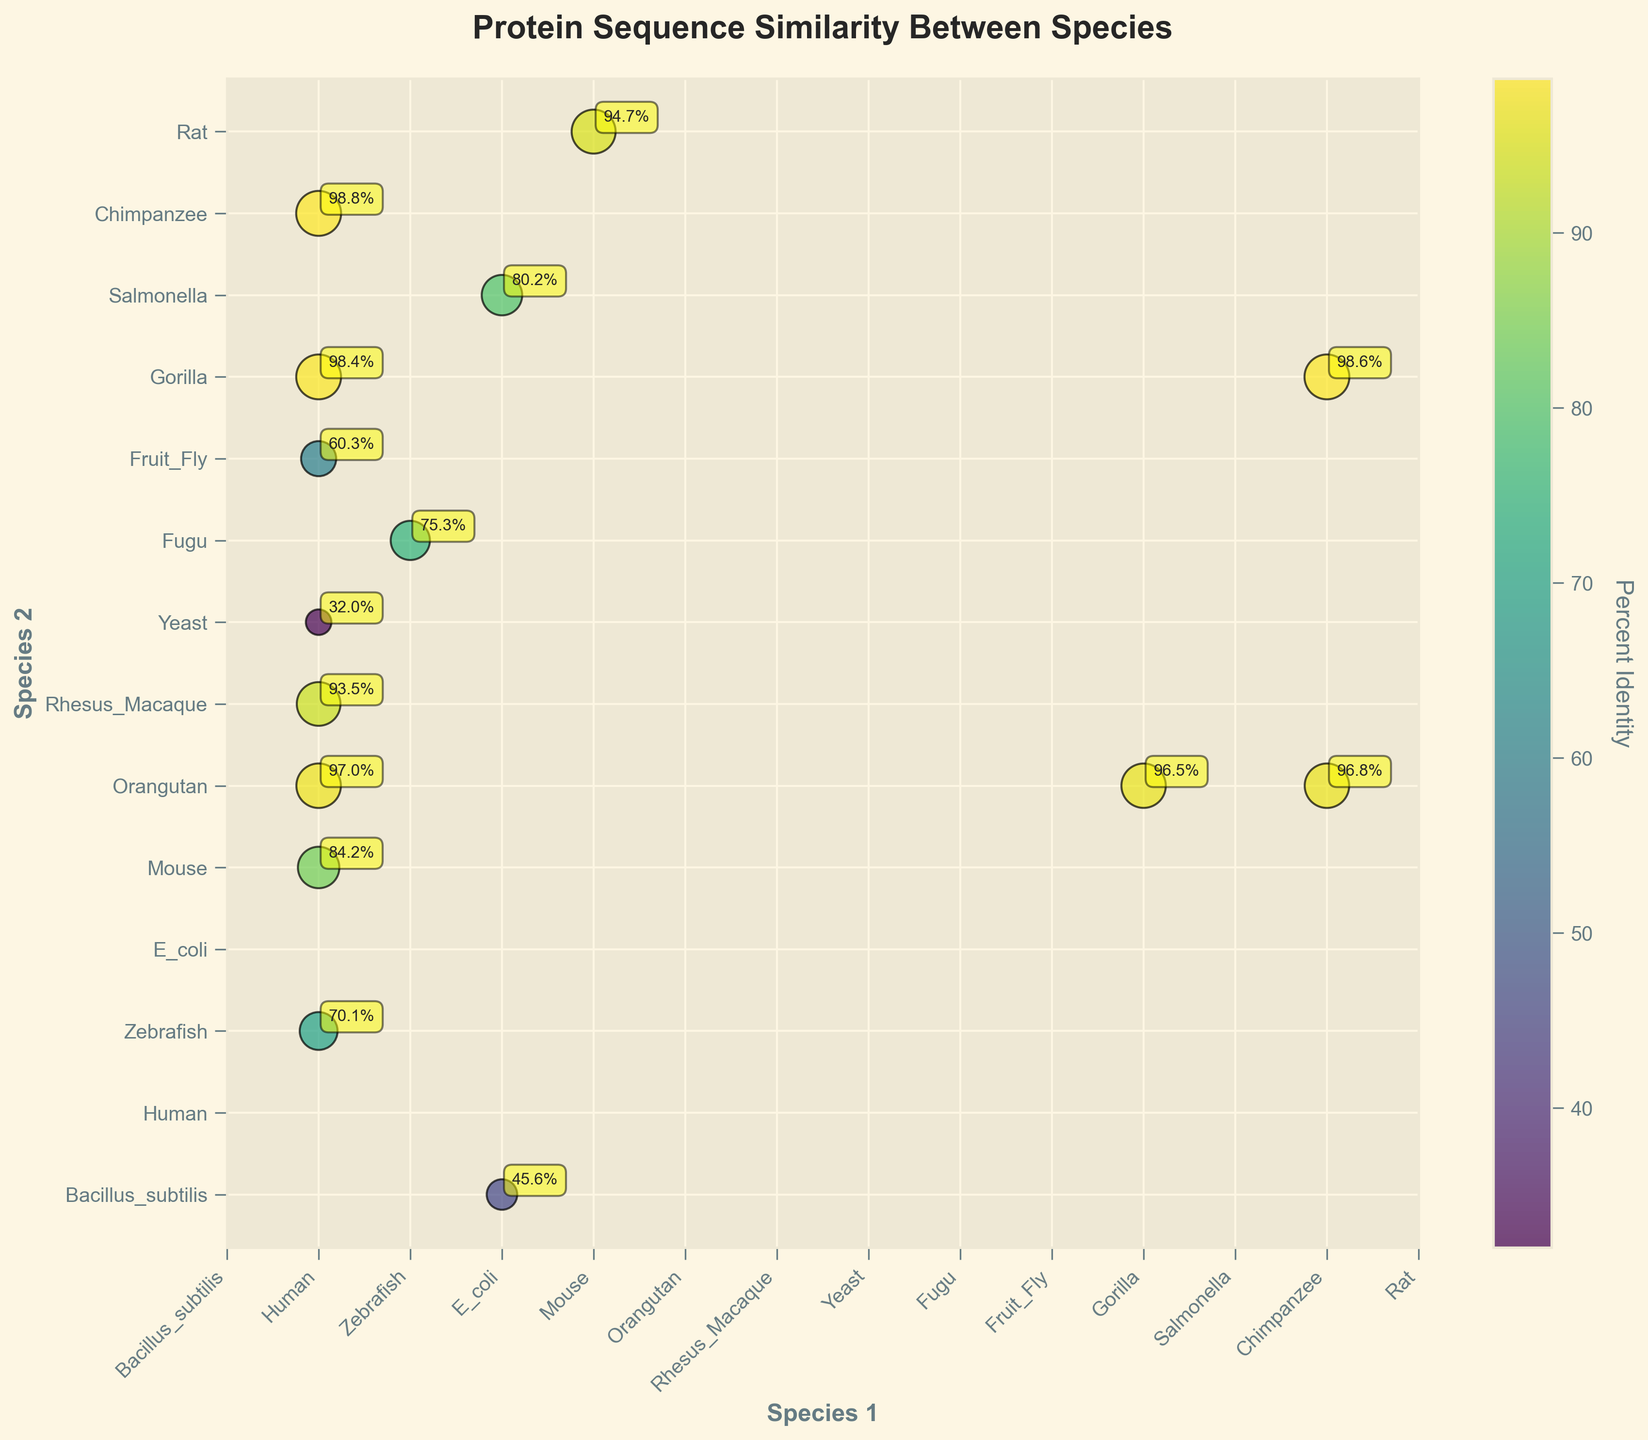what is the percent protein sequence similarity between Human and Mouse? Locate the Human and Mouse pair on the plot; the color and size of the dot indicate the percent identity, which is also annotated.
Answer: 84.2% Which species pair has the highest percent protein sequence similarity? Find the largest and darkest dot on the plot with the highest annotation. The highest percent identity is 98.8% between Human and Chimpanzee.
Answer: Human and Chimpanzee What is the title of the plot? Read the title located at the top of the plot.
Answer: Protein Sequence Similarity Between Species Are the percent identity values higher between species that are closely related taxonomically? Observe the positions and sizes of the dots; close taxonomic relatives (e.g., Human and Chimpanzee) show higher percent identities compared to distant relatives (e.g., Human and Yeast).
Answer: Yes What is the color map used in the plot? The color map is visible and matches 'viridis', with a spectrum ranging from dark to light colors.
Answer: viridis Compare the percent identity between Human-Orangutan and Mouse-Rat pairs. Refer to the annotations on the plot; Human-Orangutan has a percent identity of 97.0%, while Mouse-Rat is 94.7%.
Answer: Human-Orangutan: 97.0%, Mouse-Rat: 94.7% How many species are compared in the plot? Count the unique species names present on the x and y-axis labels. There are 14 unique species.
Answer: 14 What is the percent sequence similarity between Zebrafish and Fugu? Locate the Zebrafish and Fugu pair on the plot, and read the annotated percent identity value.
Answer: 75.3% Is there any pair with a percent identity lower than 50%? Check the plot for any dot annotations below 50%. E. coli and Bacillus subtilis have a percent identity of 45.6%.
Answer: Yes, E. coli and Bacillus subtilis Which pair shows the least percent protein sequence similarity? Find the smallest and lightest dot on the plot. The pair with the lowest percent identity is Human and Yeast at 32.0%.
Answer: Human and Yeast 